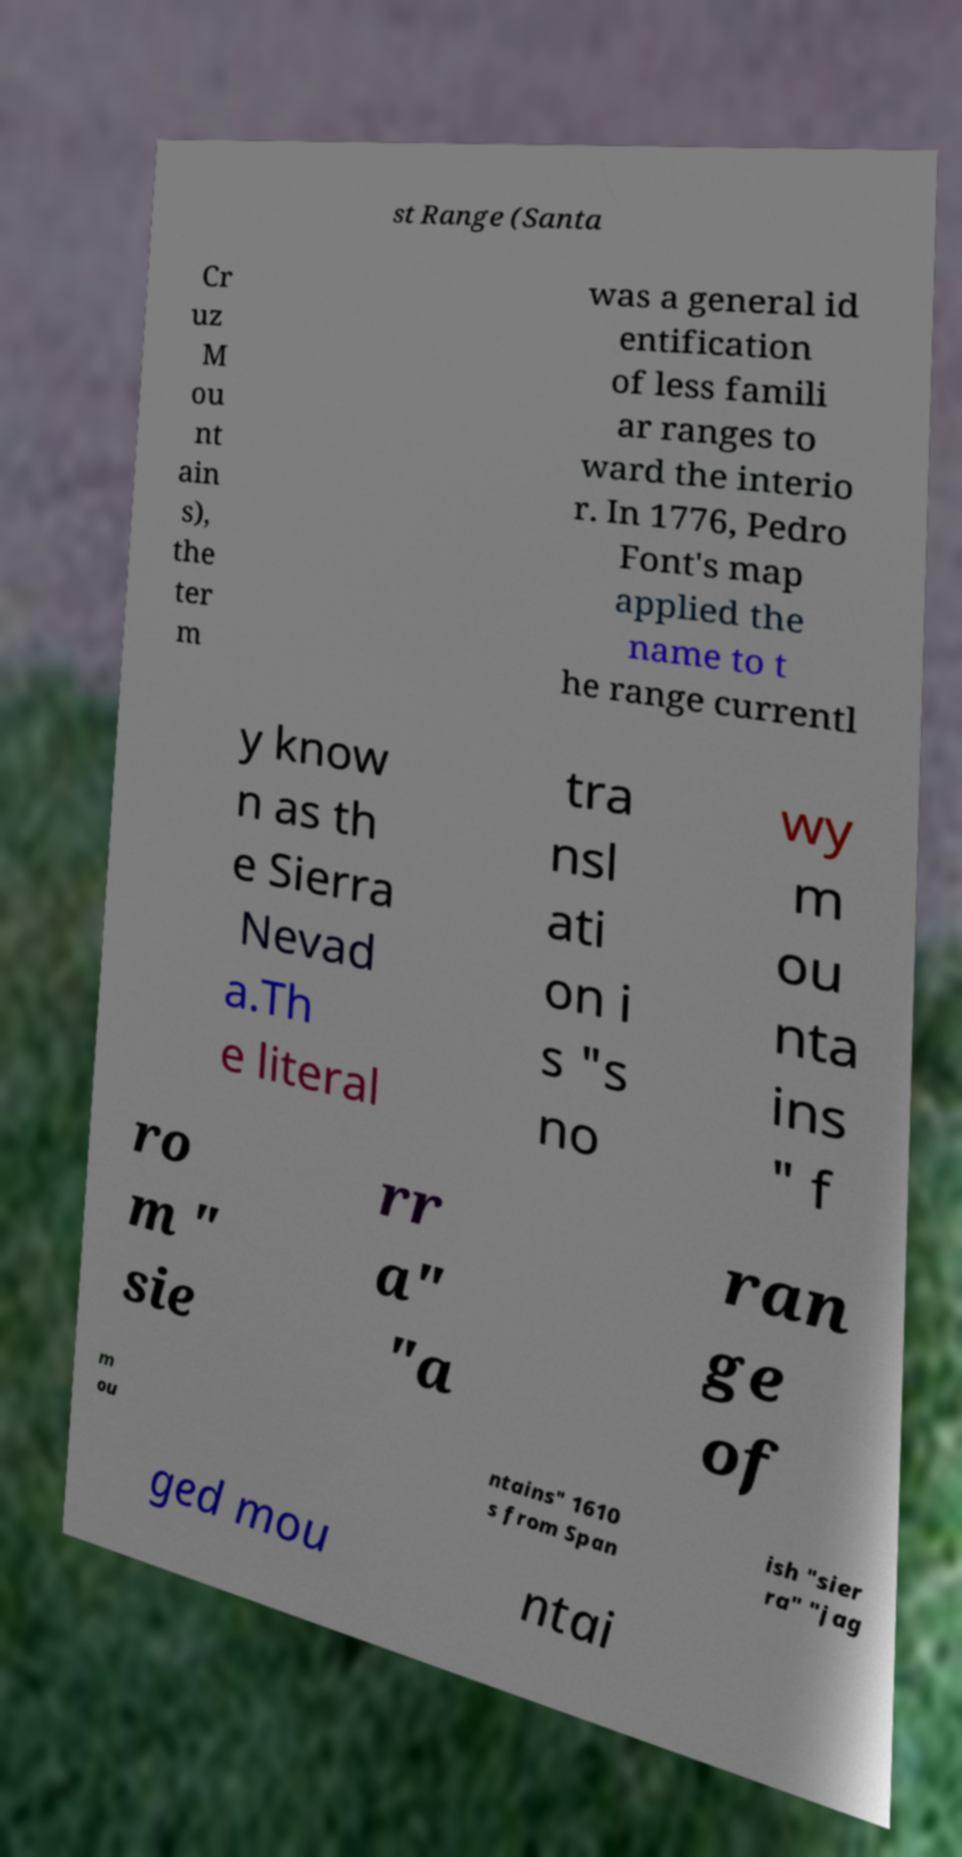Please identify and transcribe the text found in this image. st Range (Santa Cr uz M ou nt ain s), the ter m was a general id entification of less famili ar ranges to ward the interio r. In 1776, Pedro Font's map applied the name to t he range currentl y know n as th e Sierra Nevad a.Th e literal tra nsl ati on i s "s no wy m ou nta ins " f ro m " sie rr a" "a ran ge of m ou ntains" 1610 s from Span ish "sier ra" "jag ged mou ntai 